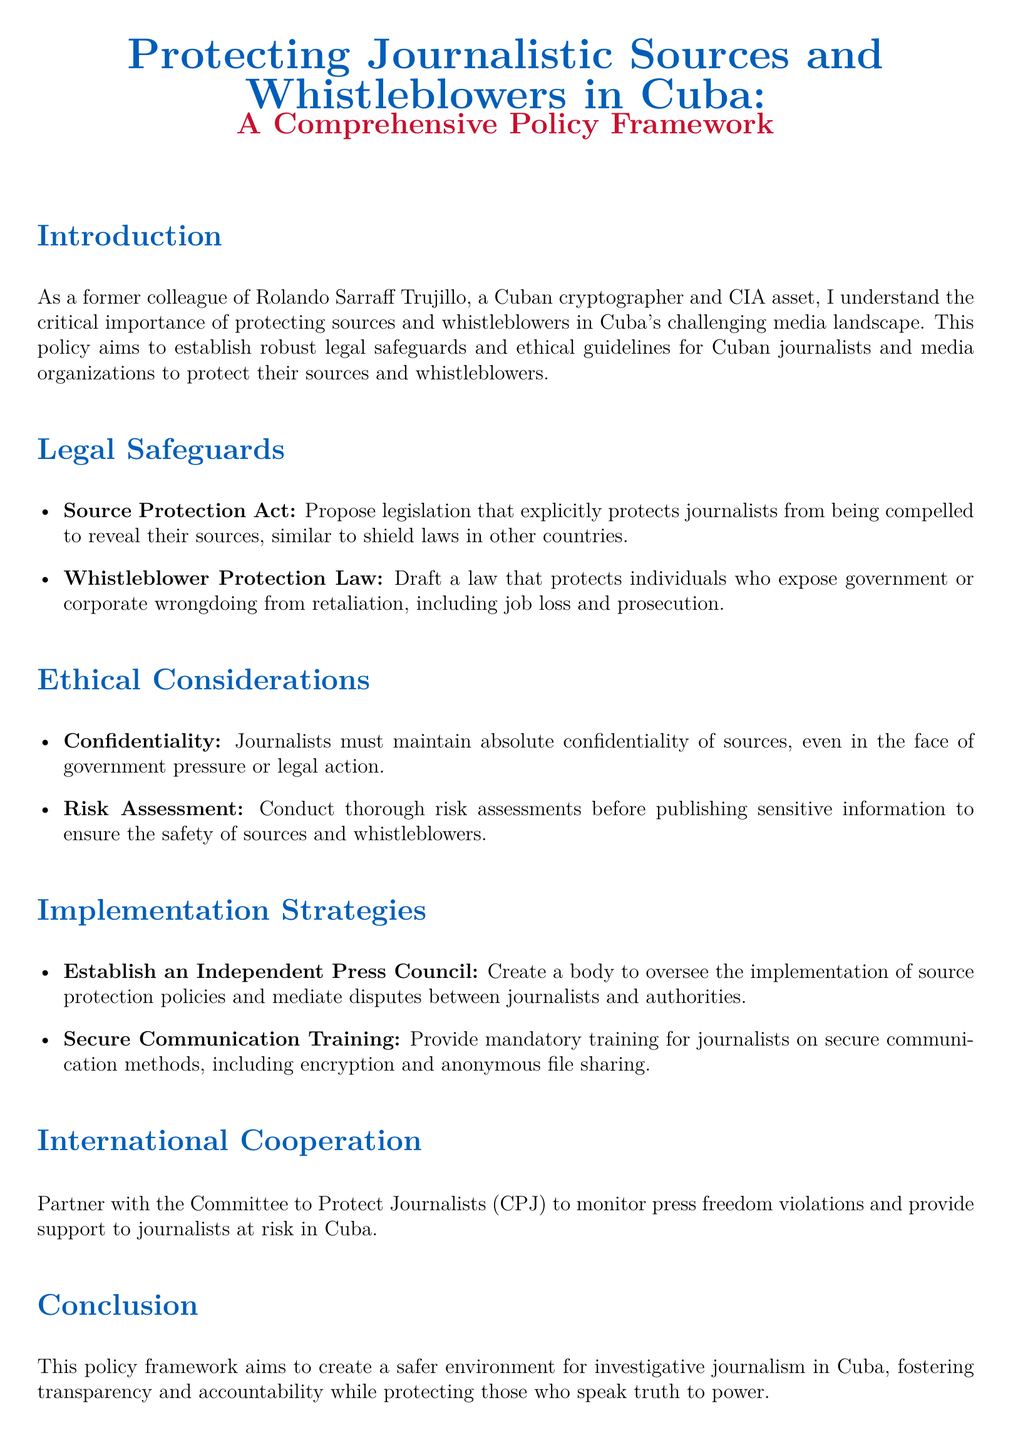What is the purpose of the policy? The purpose of the policy is to establish robust legal safeguards and ethical guidelines for Cuban journalists and media organizations to protect their sources and whistleblowers.
Answer: To establish robust legal safeguards and ethical guidelines What is included in the Legal Safeguards section? The Legal Safeguards section includes the Source Protection Act and the Whistleblower Protection Law.
Answer: Source Protection Act and Whistleblower Protection Law What must journalists maintain according to ethical considerations? The ethical considerations state that journalists must maintain absolute confidentiality of sources.
Answer: Absolute confidentiality of sources How many implementation strategies are proposed in the document? There are two implementation strategies proposed: Establish an Independent Press Council and Secure Communication Training.
Answer: Two implementation strategies Who does the document suggest partnering with for international cooperation? The document suggests partnering with the Committee to Protect Journalists (CPJ).
Answer: Committee to Protect Journalists (CPJ) What kind of training is recommended for journalists? The document recommends providing mandatory training on secure communication methods, including encryption and anonymous file sharing.
Answer: Mandatory training on secure communication methods What is the intended result of the policy framework? The intended result of the policy framework is to create a safer environment for investigative journalism in Cuba.
Answer: A safer environment for investigative journalism 